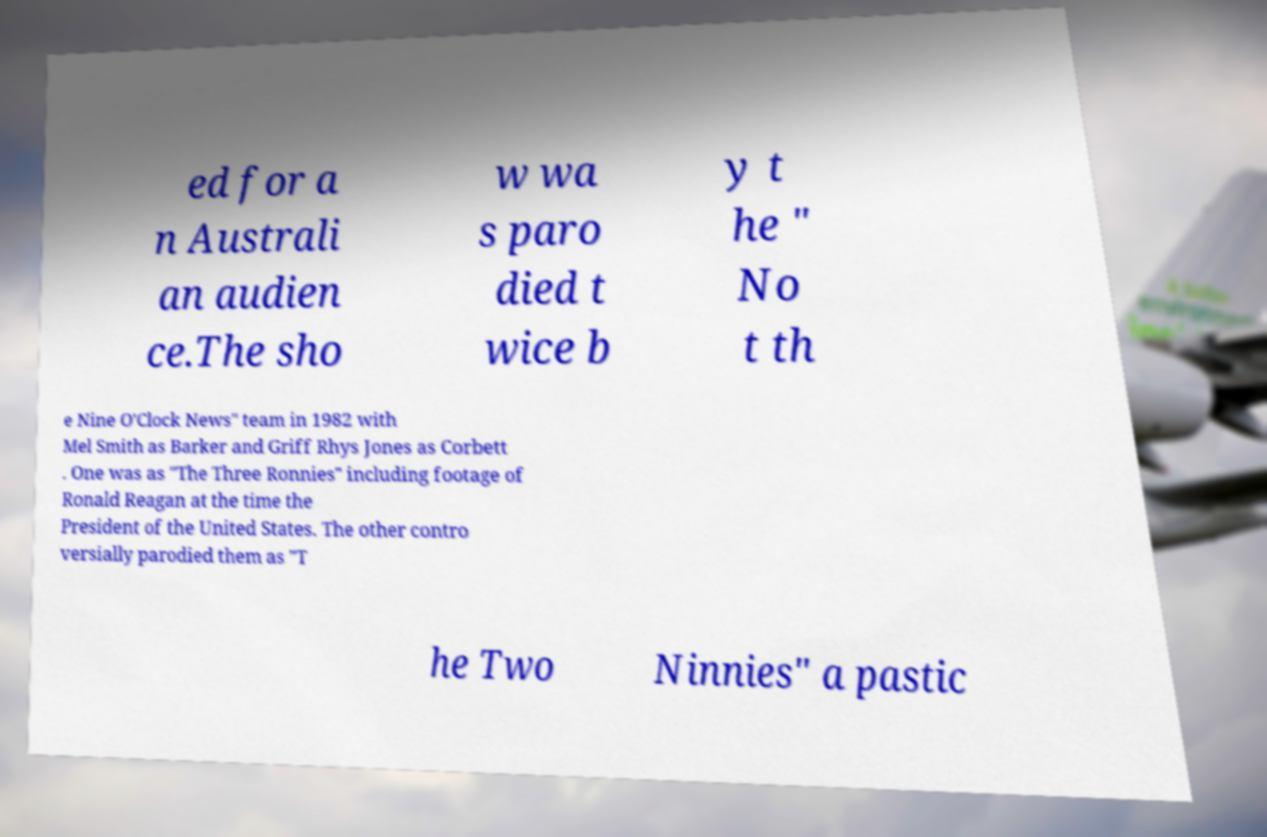Can you read and provide the text displayed in the image?This photo seems to have some interesting text. Can you extract and type it out for me? ed for a n Australi an audien ce.The sho w wa s paro died t wice b y t he " No t th e Nine O'Clock News" team in 1982 with Mel Smith as Barker and Griff Rhys Jones as Corbett . One was as "The Three Ronnies" including footage of Ronald Reagan at the time the President of the United States. The other contro versially parodied them as "T he Two Ninnies" a pastic 